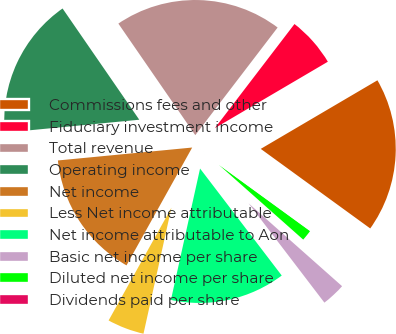<chart> <loc_0><loc_0><loc_500><loc_500><pie_chart><fcel>Commissions fees and other<fcel>Fiduciary investment income<fcel>Total revenue<fcel>Operating income<fcel>Net income<fcel>Less Net income attributable<fcel>Net income attributable to Aon<fcel>Basic net income per share<fcel>Diluted net income per share<fcel>Dividends paid per share<nl><fcel>18.46%<fcel>6.15%<fcel>20.0%<fcel>16.92%<fcel>15.38%<fcel>4.62%<fcel>13.85%<fcel>3.08%<fcel>1.54%<fcel>0.0%<nl></chart> 